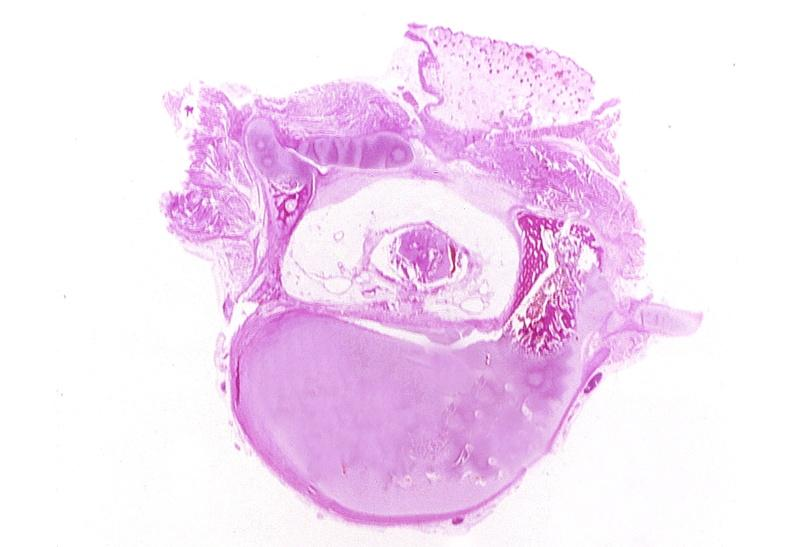does this image show neural tube defect, meningomyelocele?
Answer the question using a single word or phrase. Yes 